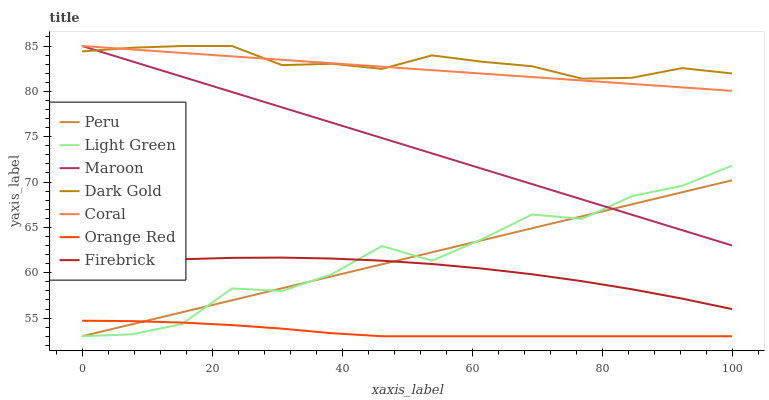Does Coral have the minimum area under the curve?
Answer yes or no. No. Does Coral have the maximum area under the curve?
Answer yes or no. No. Is Dark Gold the smoothest?
Answer yes or no. No. Is Dark Gold the roughest?
Answer yes or no. No. Does Coral have the lowest value?
Answer yes or no. No. Does Firebrick have the highest value?
Answer yes or no. No. Is Orange Red less than Firebrick?
Answer yes or no. Yes. Is Dark Gold greater than Orange Red?
Answer yes or no. Yes. Does Orange Red intersect Firebrick?
Answer yes or no. No. 